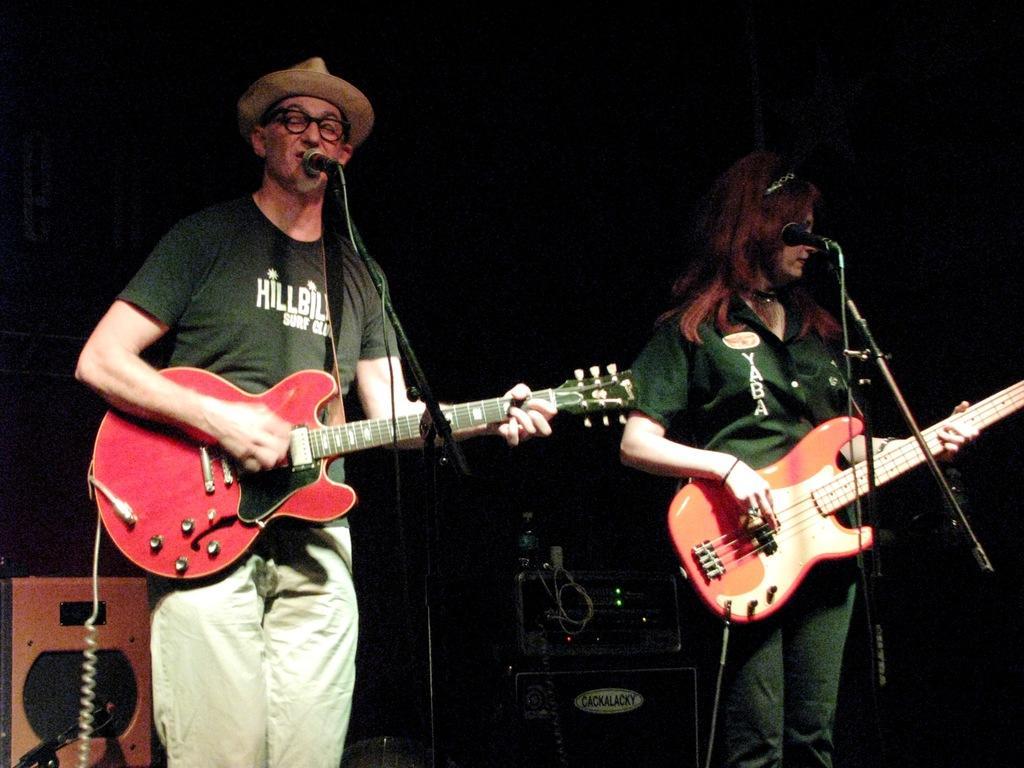Please provide a concise description of this image. In this image we can see a man and woman standing on the stage and playing the guitar in their hands. In the background we can see a speaker box and water bottle. 